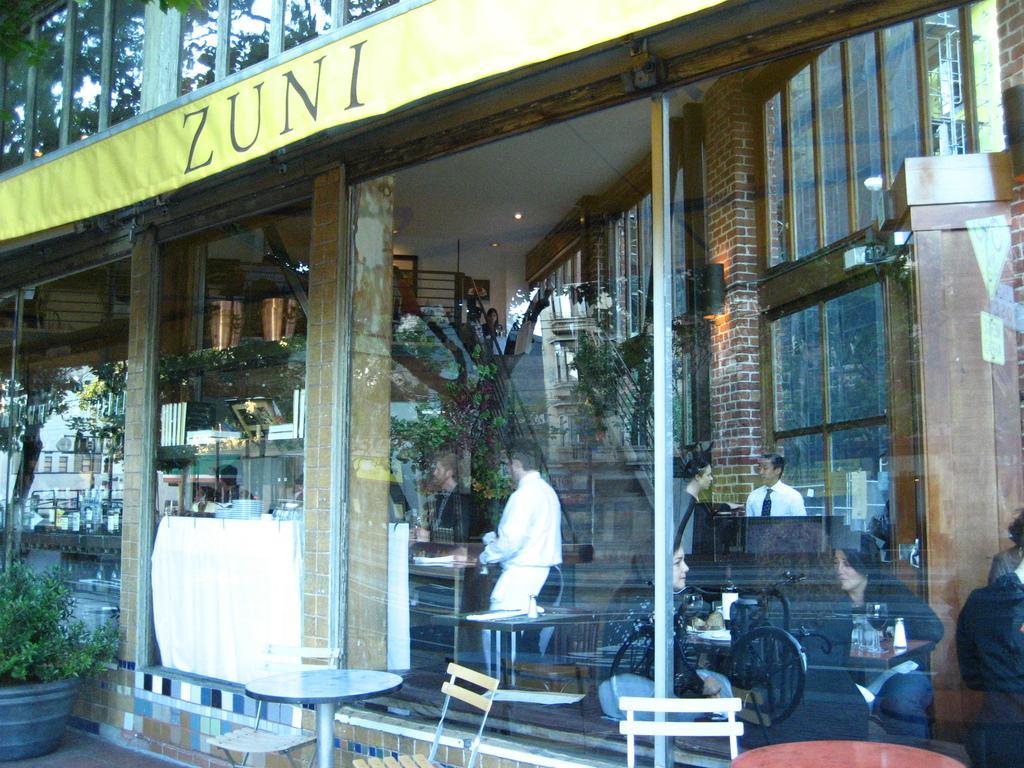In one or two sentences, can you explain what this image depicts? In this image we can see a store. In the store there are people sitting on the chairs and some are standing on the floor, objects arranged in the cupboards and the reflections of trees in the mirror. Outside the store we can see name board, houseplants, tables and chairs. 